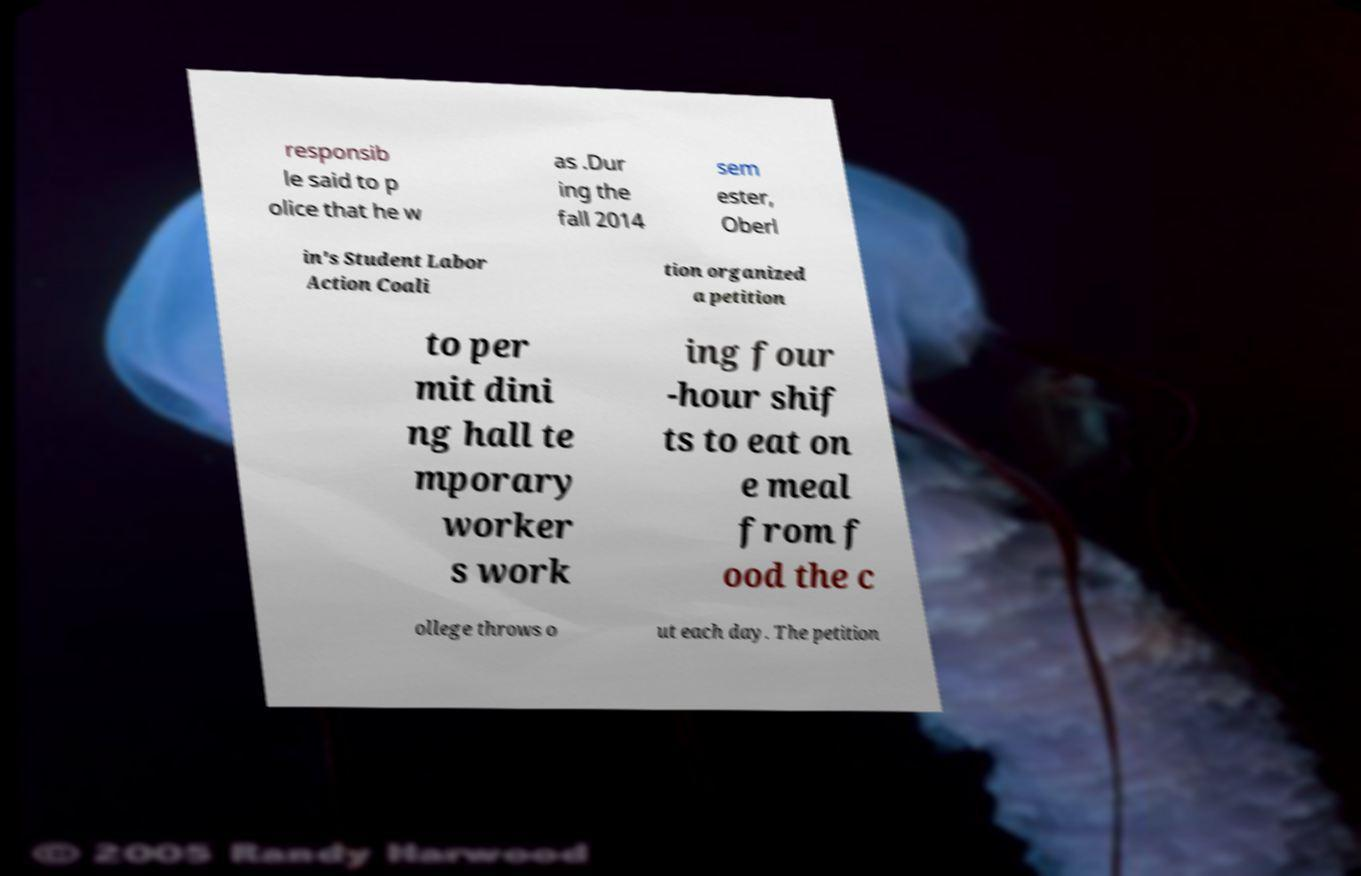There's text embedded in this image that I need extracted. Can you transcribe it verbatim? responsib le said to p olice that he w as .Dur ing the fall 2014 sem ester, Oberl in's Student Labor Action Coali tion organized a petition to per mit dini ng hall te mporary worker s work ing four -hour shif ts to eat on e meal from f ood the c ollege throws o ut each day. The petition 